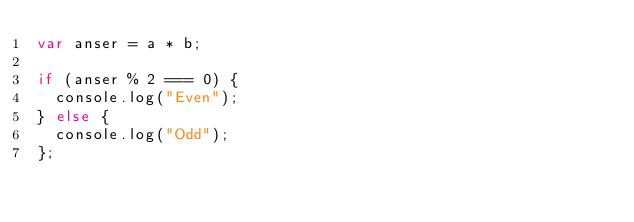Convert code to text. <code><loc_0><loc_0><loc_500><loc_500><_JavaScript_>var anser = a * b;

if (anser % 2 === 0) {
  console.log("Even");
} else {
  console.log("Odd");
};
</code> 